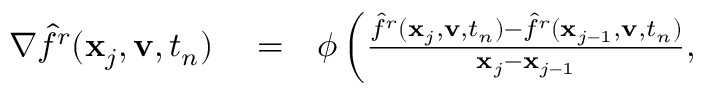Convert formula to latex. <formula><loc_0><loc_0><loc_500><loc_500>\begin{array} { r l r } { \nabla \hat { f } ^ { r } ( \mathbf x _ { j } , \mathbf v , t _ { n } ) } & = } & { \phi \left ( \frac { \hat { f } ^ { r } ( \mathbf x _ { j } , \mathbf v , t _ { n } ) - \hat { f } ^ { r } ( \mathbf x _ { j - 1 } , \mathbf v , t _ { n } ) } { \mathbf x _ { j } - \mathbf x _ { j - 1 } } , } \end{array}</formula> 